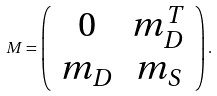Convert formula to latex. <formula><loc_0><loc_0><loc_500><loc_500>M = \left ( \begin{array} { c c } 0 & m _ { D } ^ { T } \\ m _ { D } & m _ { S } \end{array} \right ) .</formula> 